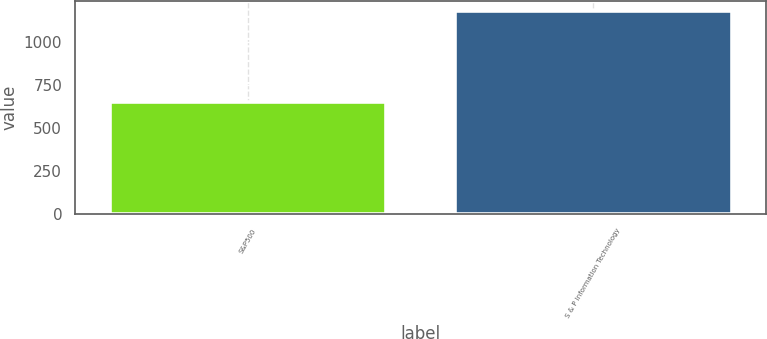Convert chart to OTSL. <chart><loc_0><loc_0><loc_500><loc_500><bar_chart><fcel>S&P500<fcel>S & P Information Technology<nl><fcel>651.53<fcel>1175.7<nl></chart> 